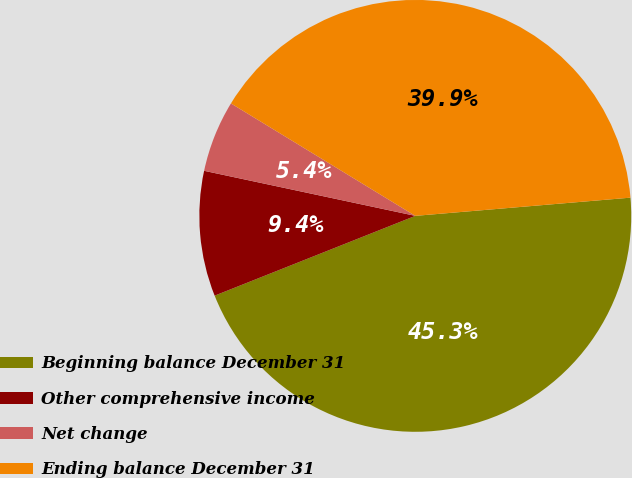Convert chart. <chart><loc_0><loc_0><loc_500><loc_500><pie_chart><fcel>Beginning balance December 31<fcel>Other comprehensive income<fcel>Net change<fcel>Ending balance December 31<nl><fcel>45.32%<fcel>9.37%<fcel>5.37%<fcel>39.94%<nl></chart> 